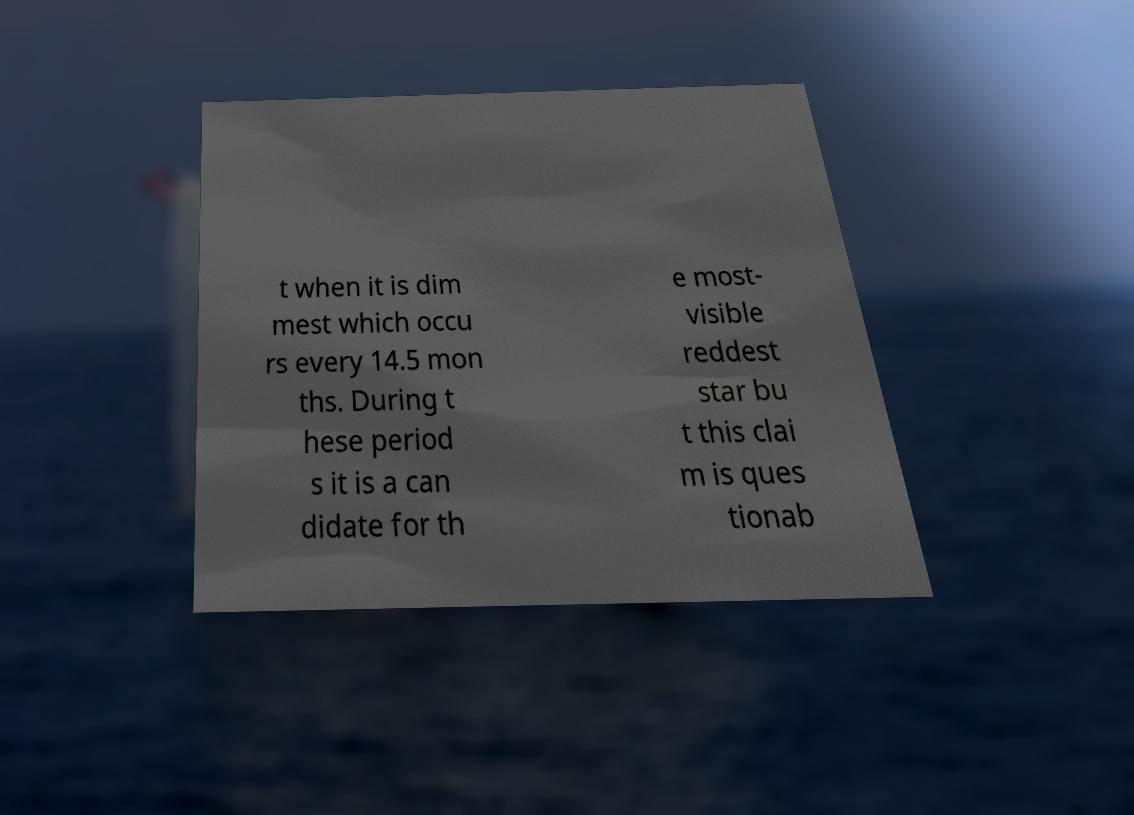Could you assist in decoding the text presented in this image and type it out clearly? t when it is dim mest which occu rs every 14.5 mon ths. During t hese period s it is a can didate for th e most- visible reddest star bu t this clai m is ques tionab 